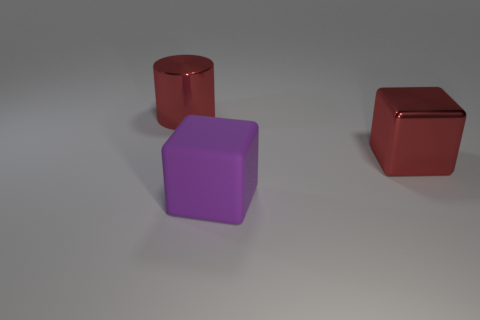There is a block in front of the metal object right of the big purple thing; what is its material?
Offer a very short reply. Rubber. The large matte cube is what color?
Offer a terse response. Purple. Are there any large things in front of the large shiny thing that is on the left side of the rubber thing?
Offer a terse response. Yes. What is the material of the purple block?
Keep it short and to the point. Rubber. Do the block that is behind the purple cube and the block that is in front of the big red metallic block have the same material?
Provide a short and direct response. No. Is there any other thing that is the same color as the shiny cylinder?
Make the answer very short. Yes. What color is the large metal object that is the same shape as the big purple matte object?
Provide a succinct answer. Red. There is a large object that is in front of the red shiny cube; is it the same shape as the big red object that is in front of the large red cylinder?
Give a very brief answer. Yes. There is a big metal object that is the same color as the cylinder; what shape is it?
Keep it short and to the point. Cube. What number of big objects have the same material as the red cylinder?
Your answer should be compact. 1. 